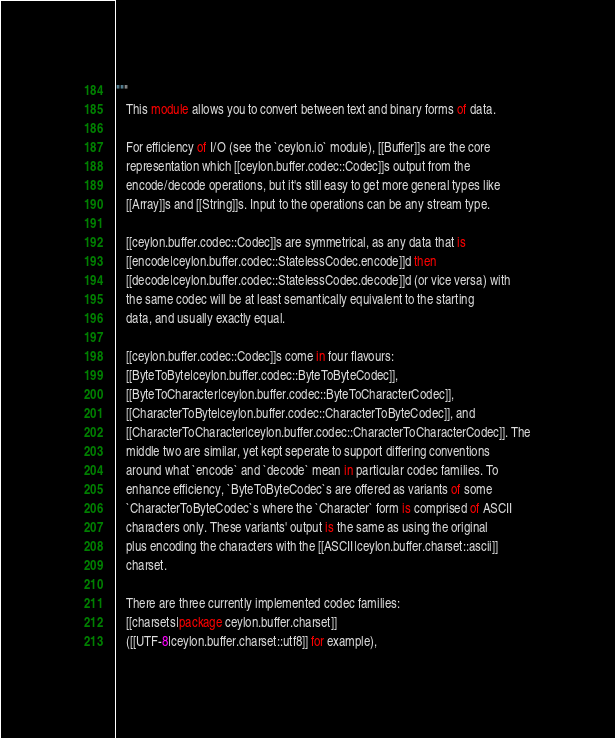<code> <loc_0><loc_0><loc_500><loc_500><_Ceylon_>"""
   This module allows you to convert between text and binary forms of data.
   
   For efficiency of I/O (see the `ceylon.io` module), [[Buffer]]s are the core
   representation which [[ceylon.buffer.codec::Codec]]s output from the
   encode/decode operations, but it's still easy to get more general types like
   [[Array]]s and [[String]]s. Input to the operations can be any stream type.
   
   [[ceylon.buffer.codec::Codec]]s are symmetrical, as any data that is
   [[encode|ceylon.buffer.codec::StatelessCodec.encode]]d then
   [[decode|ceylon.buffer.codec::StatelessCodec.decode]]d (or vice versa) with
   the same codec will be at least semantically equivalent to the starting
   data, and usually exactly equal.
   
   [[ceylon.buffer.codec::Codec]]s come in four flavours:
   [[ByteToByte|ceylon.buffer.codec::ByteToByteCodec]],
   [[ByteToCharacter|ceylon.buffer.codec::ByteToCharacterCodec]],
   [[CharacterToByte|ceylon.buffer.codec::CharacterToByteCodec]], and
   [[CharacterToCharacter|ceylon.buffer.codec::CharacterToCharacterCodec]]. The
   middle two are similar, yet kept seperate to support differing conventions
   around what `encode` and `decode` mean in particular codec families. To
   enhance efficiency, `ByteToByteCodec`s are offered as variants of some
   `CharacterToByteCodec`s where the `Character` form is comprised of ASCII
   characters only. These variants' output is the same as using the original
   plus encoding the characters with the [[ASCII|ceylon.buffer.charset::ascii]]
   charset.
   
   There are three currently implemented codec families:
   [[charsets|package ceylon.buffer.charset]]
   ([[UTF-8|ceylon.buffer.charset::utf8]] for example),</code> 